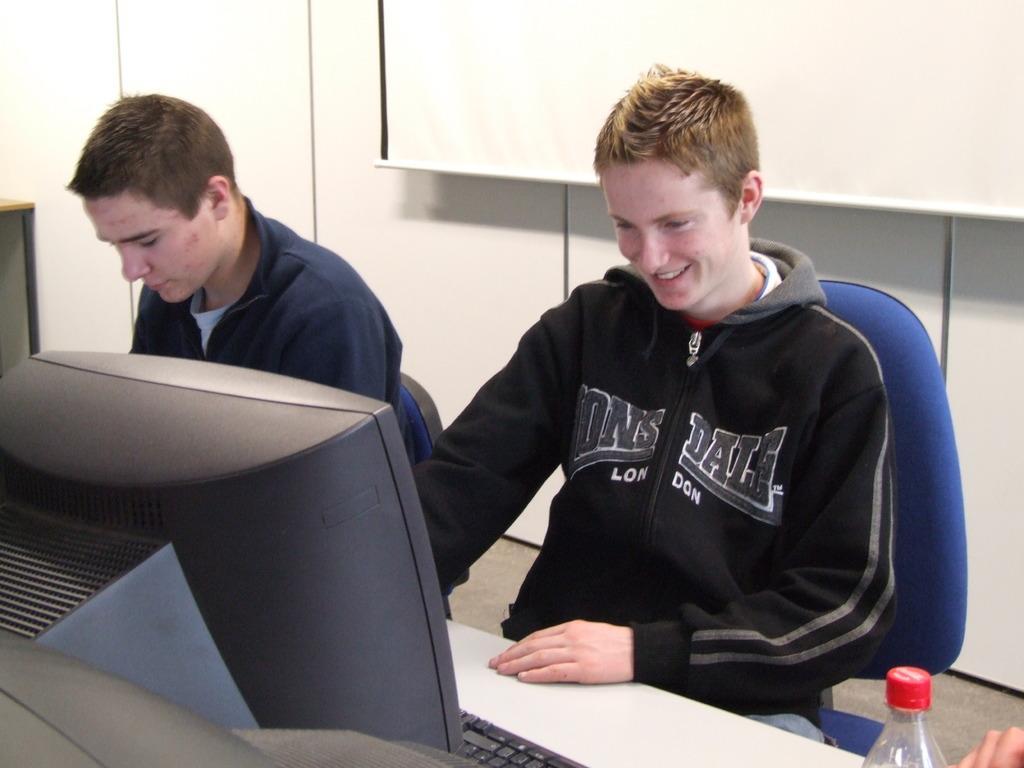Please provide a concise description of this image. This image consists of persons sitting on chair. In front of the person there are computers. In the background there is a whiteboard in front of the wall. In the center the person sitting is smiling. At the bottom right there is a bottle and the hand of the person is visible. 